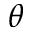Convert formula to latex. <formula><loc_0><loc_0><loc_500><loc_500>\theta</formula> 